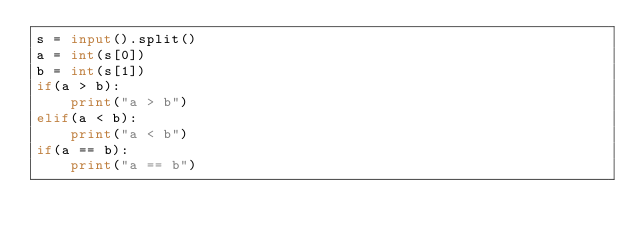Convert code to text. <code><loc_0><loc_0><loc_500><loc_500><_Python_>s = input().split()
a = int(s[0])
b = int(s[1])
if(a > b):
    print("a > b")
elif(a < b):
    print("a < b")
if(a == b):
    print("a == b")
</code> 